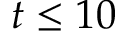Convert formula to latex. <formula><loc_0><loc_0><loc_500><loc_500>t \leq 1 0</formula> 